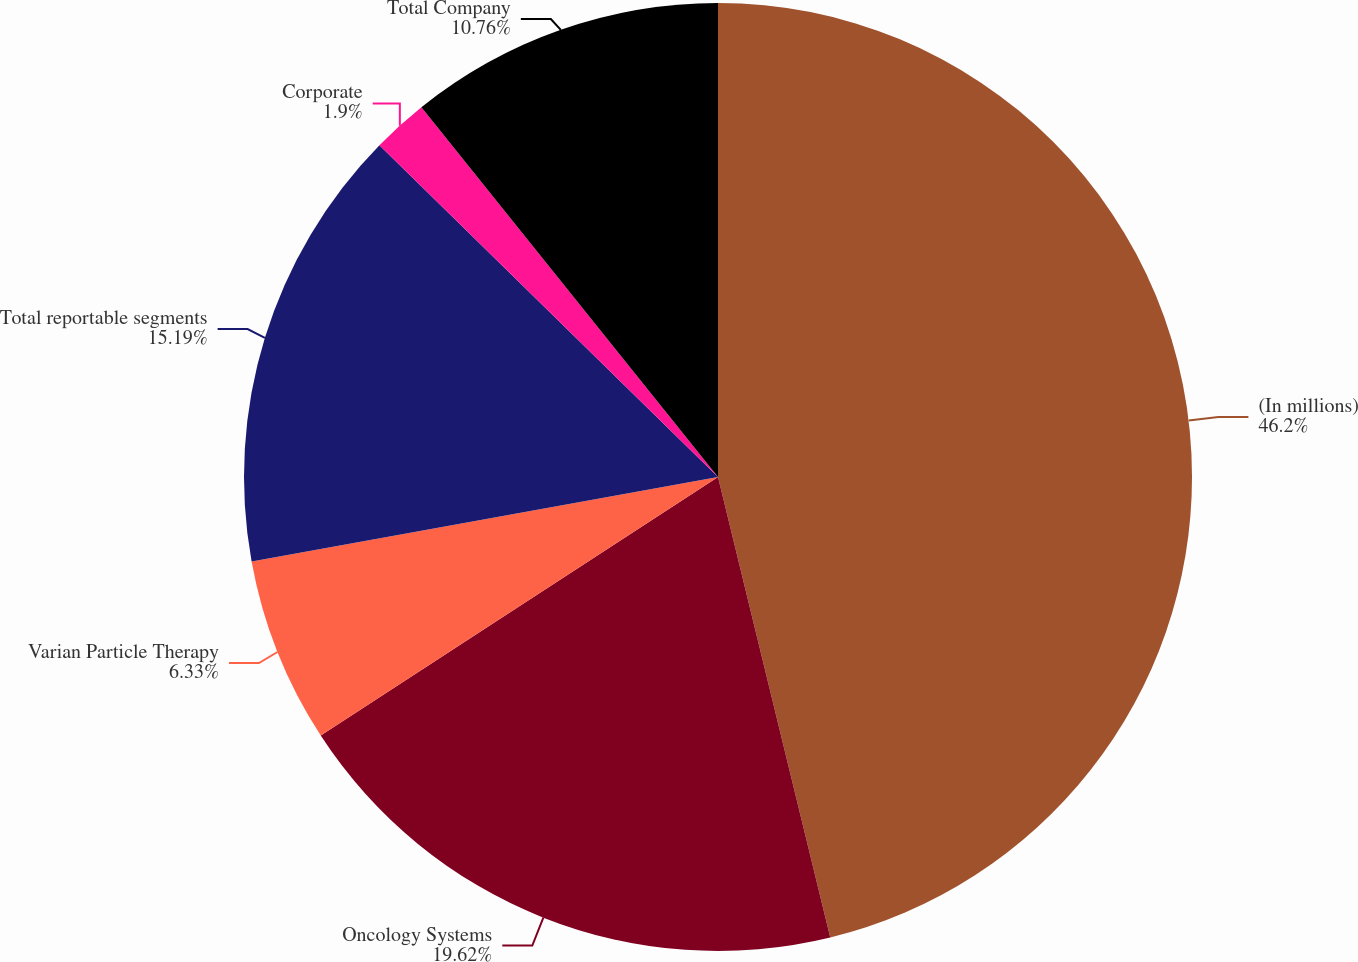<chart> <loc_0><loc_0><loc_500><loc_500><pie_chart><fcel>(In millions)<fcel>Oncology Systems<fcel>Varian Particle Therapy<fcel>Total reportable segments<fcel>Corporate<fcel>Total Company<nl><fcel>46.19%<fcel>19.62%<fcel>6.33%<fcel>15.19%<fcel>1.9%<fcel>10.76%<nl></chart> 